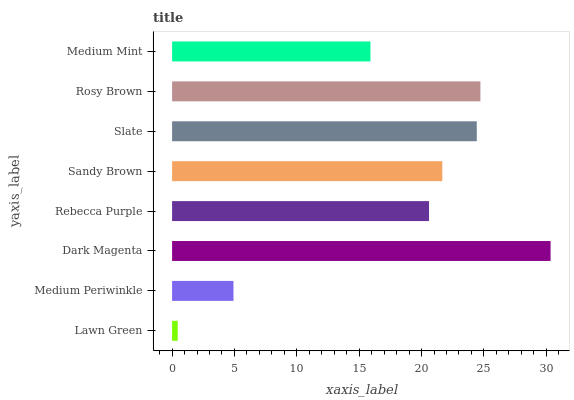Is Lawn Green the minimum?
Answer yes or no. Yes. Is Dark Magenta the maximum?
Answer yes or no. Yes. Is Medium Periwinkle the minimum?
Answer yes or no. No. Is Medium Periwinkle the maximum?
Answer yes or no. No. Is Medium Periwinkle greater than Lawn Green?
Answer yes or no. Yes. Is Lawn Green less than Medium Periwinkle?
Answer yes or no. Yes. Is Lawn Green greater than Medium Periwinkle?
Answer yes or no. No. Is Medium Periwinkle less than Lawn Green?
Answer yes or no. No. Is Sandy Brown the high median?
Answer yes or no. Yes. Is Rebecca Purple the low median?
Answer yes or no. Yes. Is Lawn Green the high median?
Answer yes or no. No. Is Rosy Brown the low median?
Answer yes or no. No. 